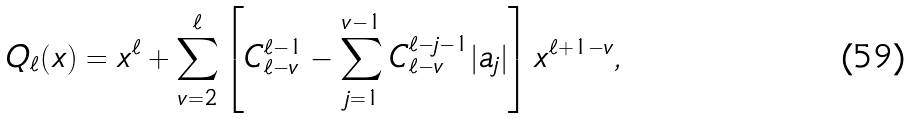Convert formula to latex. <formula><loc_0><loc_0><loc_500><loc_500>Q _ { \ell } ( x ) = x ^ { \ell } + \sum _ { v = 2 } ^ { \ell } \left [ C _ { \ell - v } ^ { \ell - 1 } - \sum _ { j = 1 } ^ { v - 1 } C _ { \ell - v } ^ { \ell - j - 1 } | a _ { j } | \right ] x ^ { \ell + 1 - v } ,</formula> 